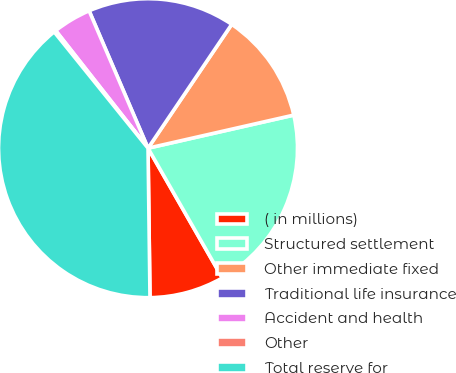<chart> <loc_0><loc_0><loc_500><loc_500><pie_chart><fcel>( in millions)<fcel>Structured settlement<fcel>Other immediate fixed<fcel>Traditional life insurance<fcel>Accident and health<fcel>Other<fcel>Total reserve for<nl><fcel>8.07%<fcel>20.28%<fcel>11.99%<fcel>15.91%<fcel>4.15%<fcel>0.21%<fcel>39.41%<nl></chart> 